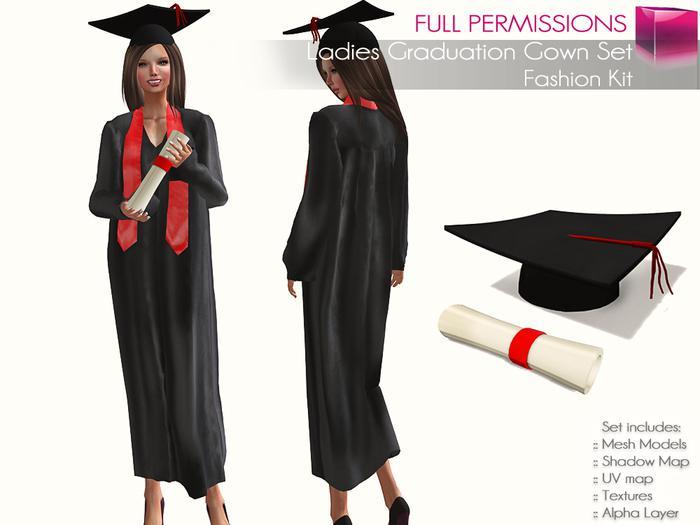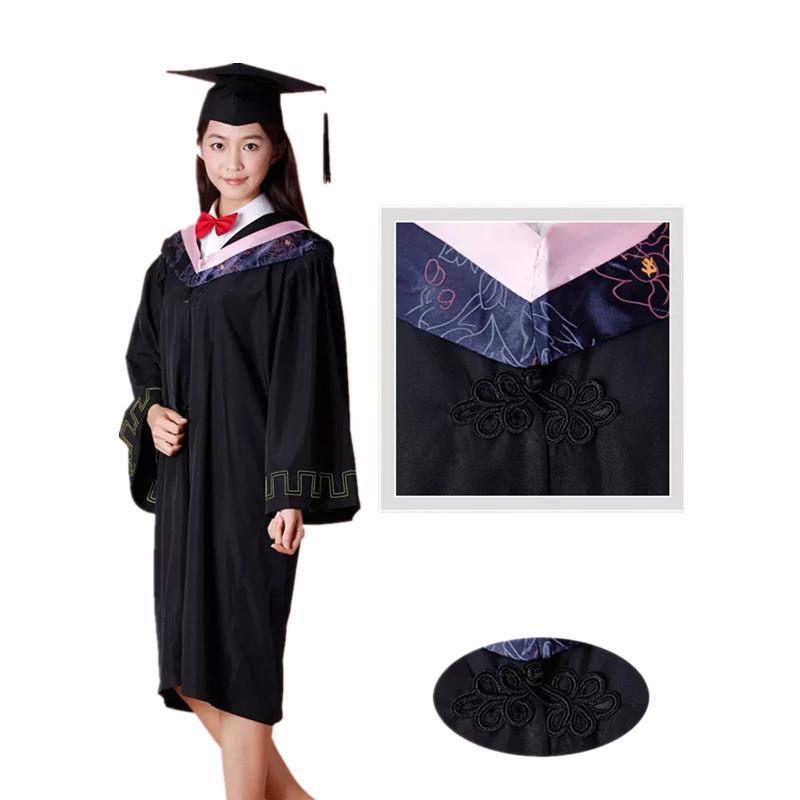The first image is the image on the left, the second image is the image on the right. Examine the images to the left and right. Is the description "There are two views of a person who is where a red sash and black graduation robe." accurate? Answer yes or no. Yes. 